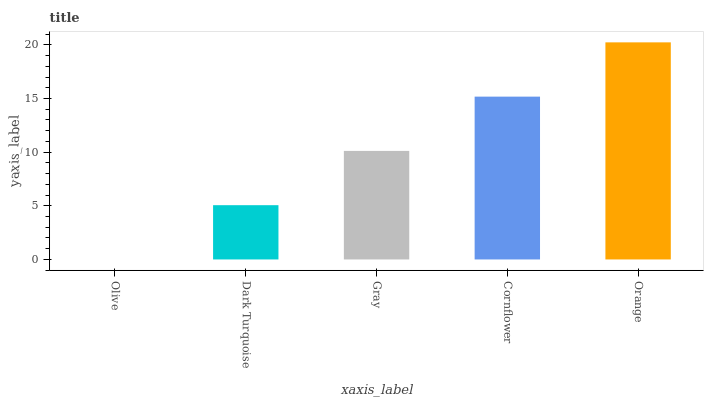Is Olive the minimum?
Answer yes or no. Yes. Is Orange the maximum?
Answer yes or no. Yes. Is Dark Turquoise the minimum?
Answer yes or no. No. Is Dark Turquoise the maximum?
Answer yes or no. No. Is Dark Turquoise greater than Olive?
Answer yes or no. Yes. Is Olive less than Dark Turquoise?
Answer yes or no. Yes. Is Olive greater than Dark Turquoise?
Answer yes or no. No. Is Dark Turquoise less than Olive?
Answer yes or no. No. Is Gray the high median?
Answer yes or no. Yes. Is Gray the low median?
Answer yes or no. Yes. Is Orange the high median?
Answer yes or no. No. Is Olive the low median?
Answer yes or no. No. 